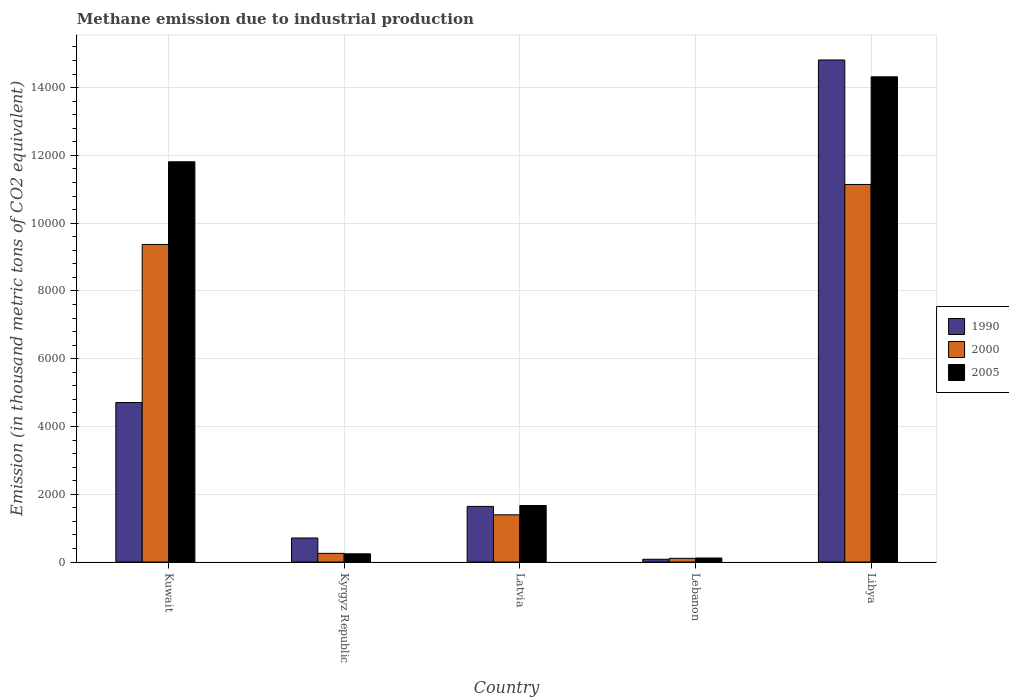How many bars are there on the 5th tick from the left?
Keep it short and to the point. 3. What is the label of the 1st group of bars from the left?
Your answer should be compact. Kuwait. What is the amount of methane emitted in 2005 in Kuwait?
Offer a terse response. 1.18e+04. Across all countries, what is the maximum amount of methane emitted in 2000?
Offer a terse response. 1.11e+04. Across all countries, what is the minimum amount of methane emitted in 1990?
Make the answer very short. 81.7. In which country was the amount of methane emitted in 2000 maximum?
Keep it short and to the point. Libya. In which country was the amount of methane emitted in 1990 minimum?
Your answer should be compact. Lebanon. What is the total amount of methane emitted in 2005 in the graph?
Your response must be concise. 2.82e+04. What is the difference between the amount of methane emitted in 1990 in Kyrgyz Republic and that in Latvia?
Provide a succinct answer. -932.7. What is the difference between the amount of methane emitted in 2000 in Libya and the amount of methane emitted in 2005 in Lebanon?
Your answer should be very brief. 1.10e+04. What is the average amount of methane emitted in 2005 per country?
Give a very brief answer. 5632.08. What is the difference between the amount of methane emitted of/in 2000 and amount of methane emitted of/in 2005 in Libya?
Your response must be concise. -3176.6. What is the ratio of the amount of methane emitted in 2005 in Kuwait to that in Latvia?
Your response must be concise. 7.08. Is the amount of methane emitted in 1990 in Latvia less than that in Libya?
Keep it short and to the point. Yes. Is the difference between the amount of methane emitted in 2000 in Lebanon and Libya greater than the difference between the amount of methane emitted in 2005 in Lebanon and Libya?
Your answer should be compact. Yes. What is the difference between the highest and the second highest amount of methane emitted in 1990?
Provide a succinct answer. -3065.5. What is the difference between the highest and the lowest amount of methane emitted in 1990?
Offer a very short reply. 1.47e+04. In how many countries, is the amount of methane emitted in 2000 greater than the average amount of methane emitted in 2000 taken over all countries?
Your answer should be very brief. 2. How many countries are there in the graph?
Your response must be concise. 5. Does the graph contain any zero values?
Offer a terse response. No. How many legend labels are there?
Your answer should be compact. 3. What is the title of the graph?
Offer a terse response. Methane emission due to industrial production. Does "1974" appear as one of the legend labels in the graph?
Give a very brief answer. No. What is the label or title of the X-axis?
Your answer should be compact. Country. What is the label or title of the Y-axis?
Offer a very short reply. Emission (in thousand metric tons of CO2 equivalent). What is the Emission (in thousand metric tons of CO2 equivalent) of 1990 in Kuwait?
Your answer should be very brief. 4707.5. What is the Emission (in thousand metric tons of CO2 equivalent) in 2000 in Kuwait?
Give a very brief answer. 9372. What is the Emission (in thousand metric tons of CO2 equivalent) in 2005 in Kuwait?
Provide a succinct answer. 1.18e+04. What is the Emission (in thousand metric tons of CO2 equivalent) in 1990 in Kyrgyz Republic?
Offer a very short reply. 709.3. What is the Emission (in thousand metric tons of CO2 equivalent) in 2000 in Kyrgyz Republic?
Keep it short and to the point. 255.9. What is the Emission (in thousand metric tons of CO2 equivalent) of 2005 in Kyrgyz Republic?
Your answer should be compact. 242.8. What is the Emission (in thousand metric tons of CO2 equivalent) of 1990 in Latvia?
Your response must be concise. 1642. What is the Emission (in thousand metric tons of CO2 equivalent) of 2000 in Latvia?
Provide a short and direct response. 1393.8. What is the Emission (in thousand metric tons of CO2 equivalent) in 2005 in Latvia?
Keep it short and to the point. 1668.3. What is the Emission (in thousand metric tons of CO2 equivalent) of 1990 in Lebanon?
Your response must be concise. 81.7. What is the Emission (in thousand metric tons of CO2 equivalent) in 2000 in Lebanon?
Provide a short and direct response. 109.7. What is the Emission (in thousand metric tons of CO2 equivalent) of 2005 in Lebanon?
Your response must be concise. 119. What is the Emission (in thousand metric tons of CO2 equivalent) in 1990 in Libya?
Make the answer very short. 1.48e+04. What is the Emission (in thousand metric tons of CO2 equivalent) of 2000 in Libya?
Give a very brief answer. 1.11e+04. What is the Emission (in thousand metric tons of CO2 equivalent) in 2005 in Libya?
Give a very brief answer. 1.43e+04. Across all countries, what is the maximum Emission (in thousand metric tons of CO2 equivalent) of 1990?
Your answer should be very brief. 1.48e+04. Across all countries, what is the maximum Emission (in thousand metric tons of CO2 equivalent) of 2000?
Offer a terse response. 1.11e+04. Across all countries, what is the maximum Emission (in thousand metric tons of CO2 equivalent) of 2005?
Your response must be concise. 1.43e+04. Across all countries, what is the minimum Emission (in thousand metric tons of CO2 equivalent) in 1990?
Ensure brevity in your answer.  81.7. Across all countries, what is the minimum Emission (in thousand metric tons of CO2 equivalent) of 2000?
Your response must be concise. 109.7. Across all countries, what is the minimum Emission (in thousand metric tons of CO2 equivalent) in 2005?
Your response must be concise. 119. What is the total Emission (in thousand metric tons of CO2 equivalent) of 1990 in the graph?
Your response must be concise. 2.20e+04. What is the total Emission (in thousand metric tons of CO2 equivalent) of 2000 in the graph?
Give a very brief answer. 2.23e+04. What is the total Emission (in thousand metric tons of CO2 equivalent) of 2005 in the graph?
Offer a terse response. 2.82e+04. What is the difference between the Emission (in thousand metric tons of CO2 equivalent) in 1990 in Kuwait and that in Kyrgyz Republic?
Provide a succinct answer. 3998.2. What is the difference between the Emission (in thousand metric tons of CO2 equivalent) in 2000 in Kuwait and that in Kyrgyz Republic?
Provide a succinct answer. 9116.1. What is the difference between the Emission (in thousand metric tons of CO2 equivalent) in 2005 in Kuwait and that in Kyrgyz Republic?
Offer a very short reply. 1.16e+04. What is the difference between the Emission (in thousand metric tons of CO2 equivalent) in 1990 in Kuwait and that in Latvia?
Ensure brevity in your answer.  3065.5. What is the difference between the Emission (in thousand metric tons of CO2 equivalent) of 2000 in Kuwait and that in Latvia?
Give a very brief answer. 7978.2. What is the difference between the Emission (in thousand metric tons of CO2 equivalent) of 2005 in Kuwait and that in Latvia?
Your answer should be compact. 1.01e+04. What is the difference between the Emission (in thousand metric tons of CO2 equivalent) in 1990 in Kuwait and that in Lebanon?
Provide a short and direct response. 4625.8. What is the difference between the Emission (in thousand metric tons of CO2 equivalent) of 2000 in Kuwait and that in Lebanon?
Offer a very short reply. 9262.3. What is the difference between the Emission (in thousand metric tons of CO2 equivalent) in 2005 in Kuwait and that in Lebanon?
Your answer should be very brief. 1.17e+04. What is the difference between the Emission (in thousand metric tons of CO2 equivalent) of 1990 in Kuwait and that in Libya?
Offer a terse response. -1.01e+04. What is the difference between the Emission (in thousand metric tons of CO2 equivalent) in 2000 in Kuwait and that in Libya?
Offer a very short reply. -1770. What is the difference between the Emission (in thousand metric tons of CO2 equivalent) of 2005 in Kuwait and that in Libya?
Make the answer very short. -2506.9. What is the difference between the Emission (in thousand metric tons of CO2 equivalent) of 1990 in Kyrgyz Republic and that in Latvia?
Keep it short and to the point. -932.7. What is the difference between the Emission (in thousand metric tons of CO2 equivalent) of 2000 in Kyrgyz Republic and that in Latvia?
Give a very brief answer. -1137.9. What is the difference between the Emission (in thousand metric tons of CO2 equivalent) in 2005 in Kyrgyz Republic and that in Latvia?
Keep it short and to the point. -1425.5. What is the difference between the Emission (in thousand metric tons of CO2 equivalent) of 1990 in Kyrgyz Republic and that in Lebanon?
Your answer should be very brief. 627.6. What is the difference between the Emission (in thousand metric tons of CO2 equivalent) in 2000 in Kyrgyz Republic and that in Lebanon?
Your answer should be very brief. 146.2. What is the difference between the Emission (in thousand metric tons of CO2 equivalent) in 2005 in Kyrgyz Republic and that in Lebanon?
Offer a terse response. 123.8. What is the difference between the Emission (in thousand metric tons of CO2 equivalent) in 1990 in Kyrgyz Republic and that in Libya?
Your answer should be compact. -1.41e+04. What is the difference between the Emission (in thousand metric tons of CO2 equivalent) in 2000 in Kyrgyz Republic and that in Libya?
Provide a succinct answer. -1.09e+04. What is the difference between the Emission (in thousand metric tons of CO2 equivalent) of 2005 in Kyrgyz Republic and that in Libya?
Make the answer very short. -1.41e+04. What is the difference between the Emission (in thousand metric tons of CO2 equivalent) of 1990 in Latvia and that in Lebanon?
Your response must be concise. 1560.3. What is the difference between the Emission (in thousand metric tons of CO2 equivalent) in 2000 in Latvia and that in Lebanon?
Your response must be concise. 1284.1. What is the difference between the Emission (in thousand metric tons of CO2 equivalent) of 2005 in Latvia and that in Lebanon?
Ensure brevity in your answer.  1549.3. What is the difference between the Emission (in thousand metric tons of CO2 equivalent) in 1990 in Latvia and that in Libya?
Give a very brief answer. -1.32e+04. What is the difference between the Emission (in thousand metric tons of CO2 equivalent) of 2000 in Latvia and that in Libya?
Give a very brief answer. -9748.2. What is the difference between the Emission (in thousand metric tons of CO2 equivalent) of 2005 in Latvia and that in Libya?
Your answer should be very brief. -1.27e+04. What is the difference between the Emission (in thousand metric tons of CO2 equivalent) in 1990 in Lebanon and that in Libya?
Provide a succinct answer. -1.47e+04. What is the difference between the Emission (in thousand metric tons of CO2 equivalent) of 2000 in Lebanon and that in Libya?
Offer a very short reply. -1.10e+04. What is the difference between the Emission (in thousand metric tons of CO2 equivalent) in 2005 in Lebanon and that in Libya?
Your answer should be compact. -1.42e+04. What is the difference between the Emission (in thousand metric tons of CO2 equivalent) in 1990 in Kuwait and the Emission (in thousand metric tons of CO2 equivalent) in 2000 in Kyrgyz Republic?
Your response must be concise. 4451.6. What is the difference between the Emission (in thousand metric tons of CO2 equivalent) in 1990 in Kuwait and the Emission (in thousand metric tons of CO2 equivalent) in 2005 in Kyrgyz Republic?
Provide a short and direct response. 4464.7. What is the difference between the Emission (in thousand metric tons of CO2 equivalent) of 2000 in Kuwait and the Emission (in thousand metric tons of CO2 equivalent) of 2005 in Kyrgyz Republic?
Your answer should be compact. 9129.2. What is the difference between the Emission (in thousand metric tons of CO2 equivalent) of 1990 in Kuwait and the Emission (in thousand metric tons of CO2 equivalent) of 2000 in Latvia?
Your answer should be compact. 3313.7. What is the difference between the Emission (in thousand metric tons of CO2 equivalent) of 1990 in Kuwait and the Emission (in thousand metric tons of CO2 equivalent) of 2005 in Latvia?
Offer a terse response. 3039.2. What is the difference between the Emission (in thousand metric tons of CO2 equivalent) of 2000 in Kuwait and the Emission (in thousand metric tons of CO2 equivalent) of 2005 in Latvia?
Offer a terse response. 7703.7. What is the difference between the Emission (in thousand metric tons of CO2 equivalent) of 1990 in Kuwait and the Emission (in thousand metric tons of CO2 equivalent) of 2000 in Lebanon?
Offer a very short reply. 4597.8. What is the difference between the Emission (in thousand metric tons of CO2 equivalent) of 1990 in Kuwait and the Emission (in thousand metric tons of CO2 equivalent) of 2005 in Lebanon?
Your answer should be compact. 4588.5. What is the difference between the Emission (in thousand metric tons of CO2 equivalent) of 2000 in Kuwait and the Emission (in thousand metric tons of CO2 equivalent) of 2005 in Lebanon?
Ensure brevity in your answer.  9253. What is the difference between the Emission (in thousand metric tons of CO2 equivalent) of 1990 in Kuwait and the Emission (in thousand metric tons of CO2 equivalent) of 2000 in Libya?
Give a very brief answer. -6434.5. What is the difference between the Emission (in thousand metric tons of CO2 equivalent) in 1990 in Kuwait and the Emission (in thousand metric tons of CO2 equivalent) in 2005 in Libya?
Make the answer very short. -9611.1. What is the difference between the Emission (in thousand metric tons of CO2 equivalent) in 2000 in Kuwait and the Emission (in thousand metric tons of CO2 equivalent) in 2005 in Libya?
Offer a terse response. -4946.6. What is the difference between the Emission (in thousand metric tons of CO2 equivalent) in 1990 in Kyrgyz Republic and the Emission (in thousand metric tons of CO2 equivalent) in 2000 in Latvia?
Give a very brief answer. -684.5. What is the difference between the Emission (in thousand metric tons of CO2 equivalent) of 1990 in Kyrgyz Republic and the Emission (in thousand metric tons of CO2 equivalent) of 2005 in Latvia?
Your answer should be very brief. -959. What is the difference between the Emission (in thousand metric tons of CO2 equivalent) of 2000 in Kyrgyz Republic and the Emission (in thousand metric tons of CO2 equivalent) of 2005 in Latvia?
Offer a terse response. -1412.4. What is the difference between the Emission (in thousand metric tons of CO2 equivalent) in 1990 in Kyrgyz Republic and the Emission (in thousand metric tons of CO2 equivalent) in 2000 in Lebanon?
Ensure brevity in your answer.  599.6. What is the difference between the Emission (in thousand metric tons of CO2 equivalent) in 1990 in Kyrgyz Republic and the Emission (in thousand metric tons of CO2 equivalent) in 2005 in Lebanon?
Provide a short and direct response. 590.3. What is the difference between the Emission (in thousand metric tons of CO2 equivalent) in 2000 in Kyrgyz Republic and the Emission (in thousand metric tons of CO2 equivalent) in 2005 in Lebanon?
Offer a very short reply. 136.9. What is the difference between the Emission (in thousand metric tons of CO2 equivalent) of 1990 in Kyrgyz Republic and the Emission (in thousand metric tons of CO2 equivalent) of 2000 in Libya?
Your response must be concise. -1.04e+04. What is the difference between the Emission (in thousand metric tons of CO2 equivalent) in 1990 in Kyrgyz Republic and the Emission (in thousand metric tons of CO2 equivalent) in 2005 in Libya?
Give a very brief answer. -1.36e+04. What is the difference between the Emission (in thousand metric tons of CO2 equivalent) of 2000 in Kyrgyz Republic and the Emission (in thousand metric tons of CO2 equivalent) of 2005 in Libya?
Ensure brevity in your answer.  -1.41e+04. What is the difference between the Emission (in thousand metric tons of CO2 equivalent) of 1990 in Latvia and the Emission (in thousand metric tons of CO2 equivalent) of 2000 in Lebanon?
Keep it short and to the point. 1532.3. What is the difference between the Emission (in thousand metric tons of CO2 equivalent) in 1990 in Latvia and the Emission (in thousand metric tons of CO2 equivalent) in 2005 in Lebanon?
Provide a succinct answer. 1523. What is the difference between the Emission (in thousand metric tons of CO2 equivalent) in 2000 in Latvia and the Emission (in thousand metric tons of CO2 equivalent) in 2005 in Lebanon?
Provide a succinct answer. 1274.8. What is the difference between the Emission (in thousand metric tons of CO2 equivalent) in 1990 in Latvia and the Emission (in thousand metric tons of CO2 equivalent) in 2000 in Libya?
Offer a terse response. -9500. What is the difference between the Emission (in thousand metric tons of CO2 equivalent) of 1990 in Latvia and the Emission (in thousand metric tons of CO2 equivalent) of 2005 in Libya?
Offer a terse response. -1.27e+04. What is the difference between the Emission (in thousand metric tons of CO2 equivalent) in 2000 in Latvia and the Emission (in thousand metric tons of CO2 equivalent) in 2005 in Libya?
Provide a succinct answer. -1.29e+04. What is the difference between the Emission (in thousand metric tons of CO2 equivalent) in 1990 in Lebanon and the Emission (in thousand metric tons of CO2 equivalent) in 2000 in Libya?
Your answer should be very brief. -1.11e+04. What is the difference between the Emission (in thousand metric tons of CO2 equivalent) in 1990 in Lebanon and the Emission (in thousand metric tons of CO2 equivalent) in 2005 in Libya?
Offer a terse response. -1.42e+04. What is the difference between the Emission (in thousand metric tons of CO2 equivalent) of 2000 in Lebanon and the Emission (in thousand metric tons of CO2 equivalent) of 2005 in Libya?
Provide a short and direct response. -1.42e+04. What is the average Emission (in thousand metric tons of CO2 equivalent) of 1990 per country?
Give a very brief answer. 4391.24. What is the average Emission (in thousand metric tons of CO2 equivalent) of 2000 per country?
Offer a very short reply. 4454.68. What is the average Emission (in thousand metric tons of CO2 equivalent) of 2005 per country?
Your response must be concise. 5632.08. What is the difference between the Emission (in thousand metric tons of CO2 equivalent) in 1990 and Emission (in thousand metric tons of CO2 equivalent) in 2000 in Kuwait?
Your response must be concise. -4664.5. What is the difference between the Emission (in thousand metric tons of CO2 equivalent) of 1990 and Emission (in thousand metric tons of CO2 equivalent) of 2005 in Kuwait?
Your answer should be very brief. -7104.2. What is the difference between the Emission (in thousand metric tons of CO2 equivalent) of 2000 and Emission (in thousand metric tons of CO2 equivalent) of 2005 in Kuwait?
Your answer should be very brief. -2439.7. What is the difference between the Emission (in thousand metric tons of CO2 equivalent) of 1990 and Emission (in thousand metric tons of CO2 equivalent) of 2000 in Kyrgyz Republic?
Your answer should be very brief. 453.4. What is the difference between the Emission (in thousand metric tons of CO2 equivalent) of 1990 and Emission (in thousand metric tons of CO2 equivalent) of 2005 in Kyrgyz Republic?
Make the answer very short. 466.5. What is the difference between the Emission (in thousand metric tons of CO2 equivalent) in 2000 and Emission (in thousand metric tons of CO2 equivalent) in 2005 in Kyrgyz Republic?
Keep it short and to the point. 13.1. What is the difference between the Emission (in thousand metric tons of CO2 equivalent) in 1990 and Emission (in thousand metric tons of CO2 equivalent) in 2000 in Latvia?
Your answer should be compact. 248.2. What is the difference between the Emission (in thousand metric tons of CO2 equivalent) in 1990 and Emission (in thousand metric tons of CO2 equivalent) in 2005 in Latvia?
Make the answer very short. -26.3. What is the difference between the Emission (in thousand metric tons of CO2 equivalent) of 2000 and Emission (in thousand metric tons of CO2 equivalent) of 2005 in Latvia?
Provide a short and direct response. -274.5. What is the difference between the Emission (in thousand metric tons of CO2 equivalent) of 1990 and Emission (in thousand metric tons of CO2 equivalent) of 2000 in Lebanon?
Your answer should be compact. -28. What is the difference between the Emission (in thousand metric tons of CO2 equivalent) of 1990 and Emission (in thousand metric tons of CO2 equivalent) of 2005 in Lebanon?
Make the answer very short. -37.3. What is the difference between the Emission (in thousand metric tons of CO2 equivalent) of 1990 and Emission (in thousand metric tons of CO2 equivalent) of 2000 in Libya?
Give a very brief answer. 3673.7. What is the difference between the Emission (in thousand metric tons of CO2 equivalent) of 1990 and Emission (in thousand metric tons of CO2 equivalent) of 2005 in Libya?
Give a very brief answer. 497.1. What is the difference between the Emission (in thousand metric tons of CO2 equivalent) of 2000 and Emission (in thousand metric tons of CO2 equivalent) of 2005 in Libya?
Make the answer very short. -3176.6. What is the ratio of the Emission (in thousand metric tons of CO2 equivalent) in 1990 in Kuwait to that in Kyrgyz Republic?
Ensure brevity in your answer.  6.64. What is the ratio of the Emission (in thousand metric tons of CO2 equivalent) in 2000 in Kuwait to that in Kyrgyz Republic?
Offer a very short reply. 36.62. What is the ratio of the Emission (in thousand metric tons of CO2 equivalent) in 2005 in Kuwait to that in Kyrgyz Republic?
Keep it short and to the point. 48.65. What is the ratio of the Emission (in thousand metric tons of CO2 equivalent) of 1990 in Kuwait to that in Latvia?
Offer a terse response. 2.87. What is the ratio of the Emission (in thousand metric tons of CO2 equivalent) in 2000 in Kuwait to that in Latvia?
Give a very brief answer. 6.72. What is the ratio of the Emission (in thousand metric tons of CO2 equivalent) of 2005 in Kuwait to that in Latvia?
Keep it short and to the point. 7.08. What is the ratio of the Emission (in thousand metric tons of CO2 equivalent) in 1990 in Kuwait to that in Lebanon?
Make the answer very short. 57.62. What is the ratio of the Emission (in thousand metric tons of CO2 equivalent) in 2000 in Kuwait to that in Lebanon?
Your answer should be very brief. 85.43. What is the ratio of the Emission (in thousand metric tons of CO2 equivalent) in 2005 in Kuwait to that in Lebanon?
Provide a succinct answer. 99.26. What is the ratio of the Emission (in thousand metric tons of CO2 equivalent) of 1990 in Kuwait to that in Libya?
Ensure brevity in your answer.  0.32. What is the ratio of the Emission (in thousand metric tons of CO2 equivalent) in 2000 in Kuwait to that in Libya?
Make the answer very short. 0.84. What is the ratio of the Emission (in thousand metric tons of CO2 equivalent) in 2005 in Kuwait to that in Libya?
Your answer should be compact. 0.82. What is the ratio of the Emission (in thousand metric tons of CO2 equivalent) in 1990 in Kyrgyz Republic to that in Latvia?
Your answer should be very brief. 0.43. What is the ratio of the Emission (in thousand metric tons of CO2 equivalent) in 2000 in Kyrgyz Republic to that in Latvia?
Offer a terse response. 0.18. What is the ratio of the Emission (in thousand metric tons of CO2 equivalent) in 2005 in Kyrgyz Republic to that in Latvia?
Offer a terse response. 0.15. What is the ratio of the Emission (in thousand metric tons of CO2 equivalent) of 1990 in Kyrgyz Republic to that in Lebanon?
Your response must be concise. 8.68. What is the ratio of the Emission (in thousand metric tons of CO2 equivalent) of 2000 in Kyrgyz Republic to that in Lebanon?
Provide a short and direct response. 2.33. What is the ratio of the Emission (in thousand metric tons of CO2 equivalent) in 2005 in Kyrgyz Republic to that in Lebanon?
Your answer should be very brief. 2.04. What is the ratio of the Emission (in thousand metric tons of CO2 equivalent) in 1990 in Kyrgyz Republic to that in Libya?
Make the answer very short. 0.05. What is the ratio of the Emission (in thousand metric tons of CO2 equivalent) of 2000 in Kyrgyz Republic to that in Libya?
Your response must be concise. 0.02. What is the ratio of the Emission (in thousand metric tons of CO2 equivalent) in 2005 in Kyrgyz Republic to that in Libya?
Ensure brevity in your answer.  0.02. What is the ratio of the Emission (in thousand metric tons of CO2 equivalent) in 1990 in Latvia to that in Lebanon?
Give a very brief answer. 20.1. What is the ratio of the Emission (in thousand metric tons of CO2 equivalent) in 2000 in Latvia to that in Lebanon?
Your answer should be very brief. 12.71. What is the ratio of the Emission (in thousand metric tons of CO2 equivalent) of 2005 in Latvia to that in Lebanon?
Your answer should be compact. 14.02. What is the ratio of the Emission (in thousand metric tons of CO2 equivalent) in 1990 in Latvia to that in Libya?
Provide a short and direct response. 0.11. What is the ratio of the Emission (in thousand metric tons of CO2 equivalent) in 2000 in Latvia to that in Libya?
Give a very brief answer. 0.13. What is the ratio of the Emission (in thousand metric tons of CO2 equivalent) in 2005 in Latvia to that in Libya?
Your answer should be compact. 0.12. What is the ratio of the Emission (in thousand metric tons of CO2 equivalent) in 1990 in Lebanon to that in Libya?
Your response must be concise. 0.01. What is the ratio of the Emission (in thousand metric tons of CO2 equivalent) of 2000 in Lebanon to that in Libya?
Make the answer very short. 0.01. What is the ratio of the Emission (in thousand metric tons of CO2 equivalent) of 2005 in Lebanon to that in Libya?
Offer a terse response. 0.01. What is the difference between the highest and the second highest Emission (in thousand metric tons of CO2 equivalent) of 1990?
Give a very brief answer. 1.01e+04. What is the difference between the highest and the second highest Emission (in thousand metric tons of CO2 equivalent) in 2000?
Ensure brevity in your answer.  1770. What is the difference between the highest and the second highest Emission (in thousand metric tons of CO2 equivalent) of 2005?
Offer a very short reply. 2506.9. What is the difference between the highest and the lowest Emission (in thousand metric tons of CO2 equivalent) of 1990?
Provide a succinct answer. 1.47e+04. What is the difference between the highest and the lowest Emission (in thousand metric tons of CO2 equivalent) in 2000?
Keep it short and to the point. 1.10e+04. What is the difference between the highest and the lowest Emission (in thousand metric tons of CO2 equivalent) in 2005?
Your answer should be compact. 1.42e+04. 